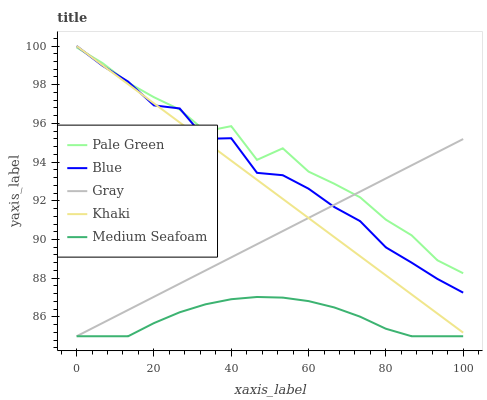Does Medium Seafoam have the minimum area under the curve?
Answer yes or no. Yes. Does Pale Green have the maximum area under the curve?
Answer yes or no. Yes. Does Gray have the minimum area under the curve?
Answer yes or no. No. Does Gray have the maximum area under the curve?
Answer yes or no. No. Is Khaki the smoothest?
Answer yes or no. Yes. Is Pale Green the roughest?
Answer yes or no. Yes. Is Gray the smoothest?
Answer yes or no. No. Is Gray the roughest?
Answer yes or no. No. Does Gray have the lowest value?
Answer yes or no. Yes. Does Pale Green have the lowest value?
Answer yes or no. No. Does Khaki have the highest value?
Answer yes or no. Yes. Does Gray have the highest value?
Answer yes or no. No. Is Medium Seafoam less than Khaki?
Answer yes or no. Yes. Is Blue greater than Medium Seafoam?
Answer yes or no. Yes. Does Khaki intersect Blue?
Answer yes or no. Yes. Is Khaki less than Blue?
Answer yes or no. No. Is Khaki greater than Blue?
Answer yes or no. No. Does Medium Seafoam intersect Khaki?
Answer yes or no. No. 